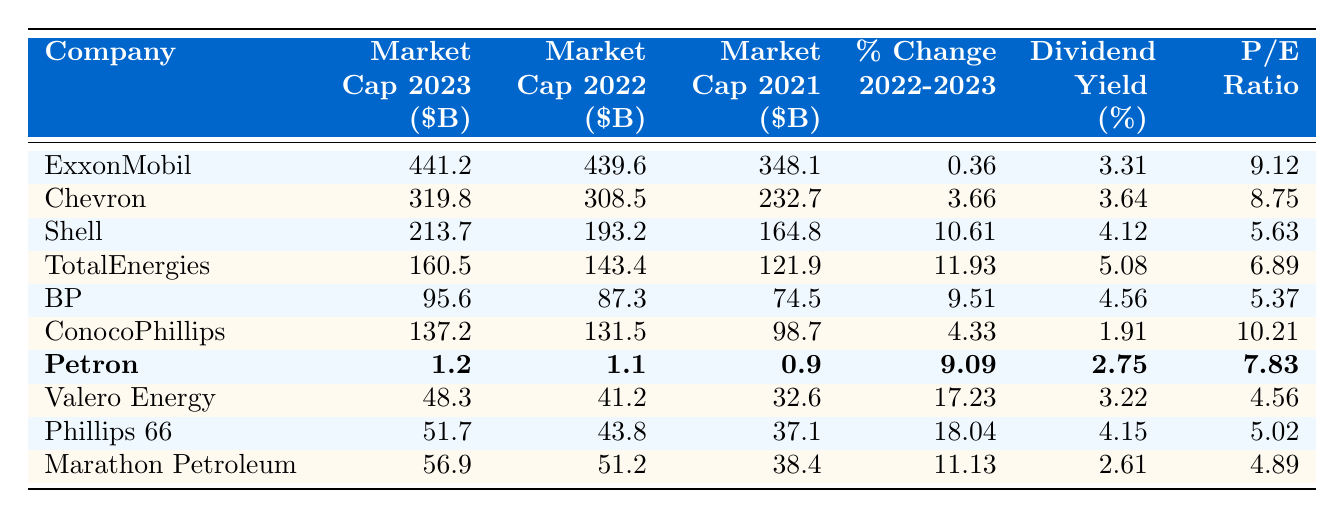What is the market capitalization of Petron in 2023? The table shows the market capitalization for each company in 2023. Petron's market cap is listed as 1.2 billion dollars.
Answer: 1.2 billion dollars Which company had the highest market capitalization in 2023? Looking at the market capitalization values for 2023, ExxonMobil has the highest at 441.2 billion dollars.
Answer: ExxonMobil What was the market capitalization of BP in 2022? According to the table, BP's market capitalization in 2022 is 87.3 billion dollars.
Answer: 87.3 billion dollars What is the percent change in market capitalization for Valero Energy from 2022 to 2023? The percent change from 2022 to 2023 for Valero Energy can be found in the table, which indicates a change of 17.23%.
Answer: 17.23% Which company experienced the largest percentage increase in market capitalization from 2022 to 2023? To determine this, we check the percent change values. Valero Energy has the highest increase at 17.23%.
Answer: Valero Energy What is the dividend yield of Shell? The table indicates Shell has a dividend yield of 4.12%.
Answer: 4.12% What is the average market capitalization of the top three companies listed in 2023? The market capitalizations for the top three companies (ExxonMobil, Chevron, Shell) are 441.2, 319.8, and 213.7 billion dollars. Summing these gives 974.7 billion dollars. Dividing by 3 results in an average of 324.9 billion dollars.
Answer: 324.9 billion dollars Which company had the lowest market capitalization in 2021, and what was that value? By reviewing the 2021 market capitalization values, Petron had the lowest market cap at 0.9 billion dollars.
Answer: Petron, 0.9 billion dollars Did TotalEnergies have a higher market capitalization in 2022 or 2021? A comparison of TotalEnergies' market caps reveals it was lower in 2021 (121.9 billion dollars) compared to 2022 (143.4 billion dollars). Therefore, 2022 is higher.
Answer: Yes, 2022 was higher If we compare the dividend yields of BP and ConocoPhillips, which one is higher? The dividend yields are 4.56% for BP and 1.91% for ConocoPhillips, indicating that BP has a higher yield.
Answer: BP has a higher yield 